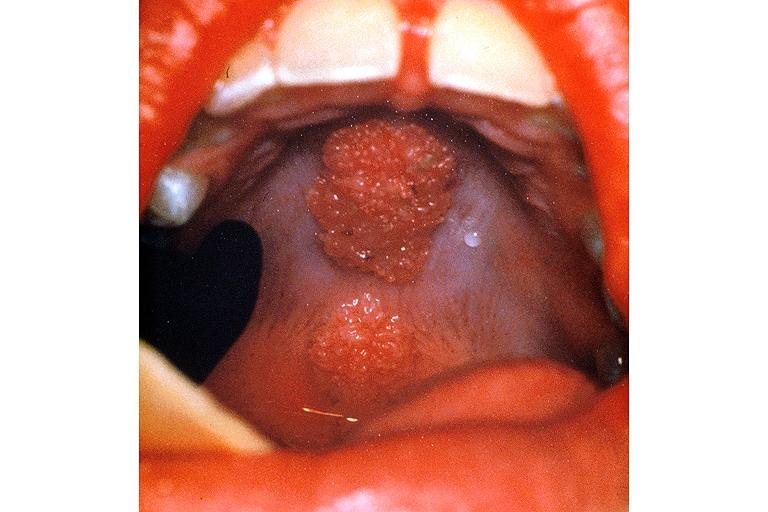what does this image show?
Answer the question using a single word or phrase. Condyloma accuminatum 